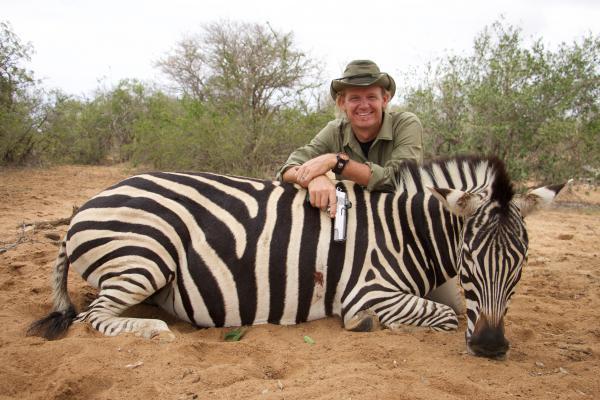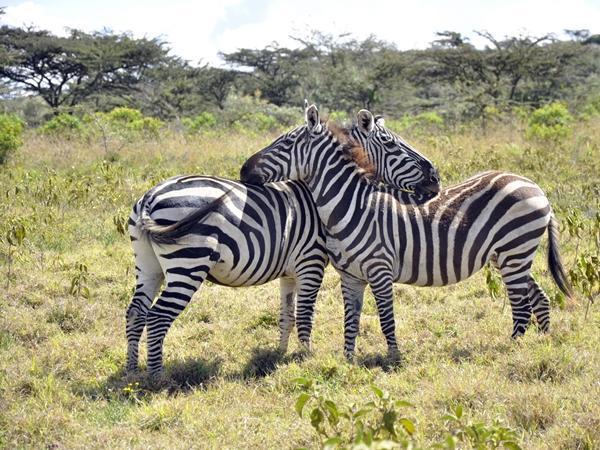The first image is the image on the left, the second image is the image on the right. For the images displayed, is the sentence "The image on the right shows two zebras embracing each other with their heads." factually correct? Answer yes or no. Yes. The first image is the image on the left, the second image is the image on the right. For the images shown, is this caption "One image shows two zebra standing in profile turned toward one another, each one with its head over the back of the other." true? Answer yes or no. Yes. 